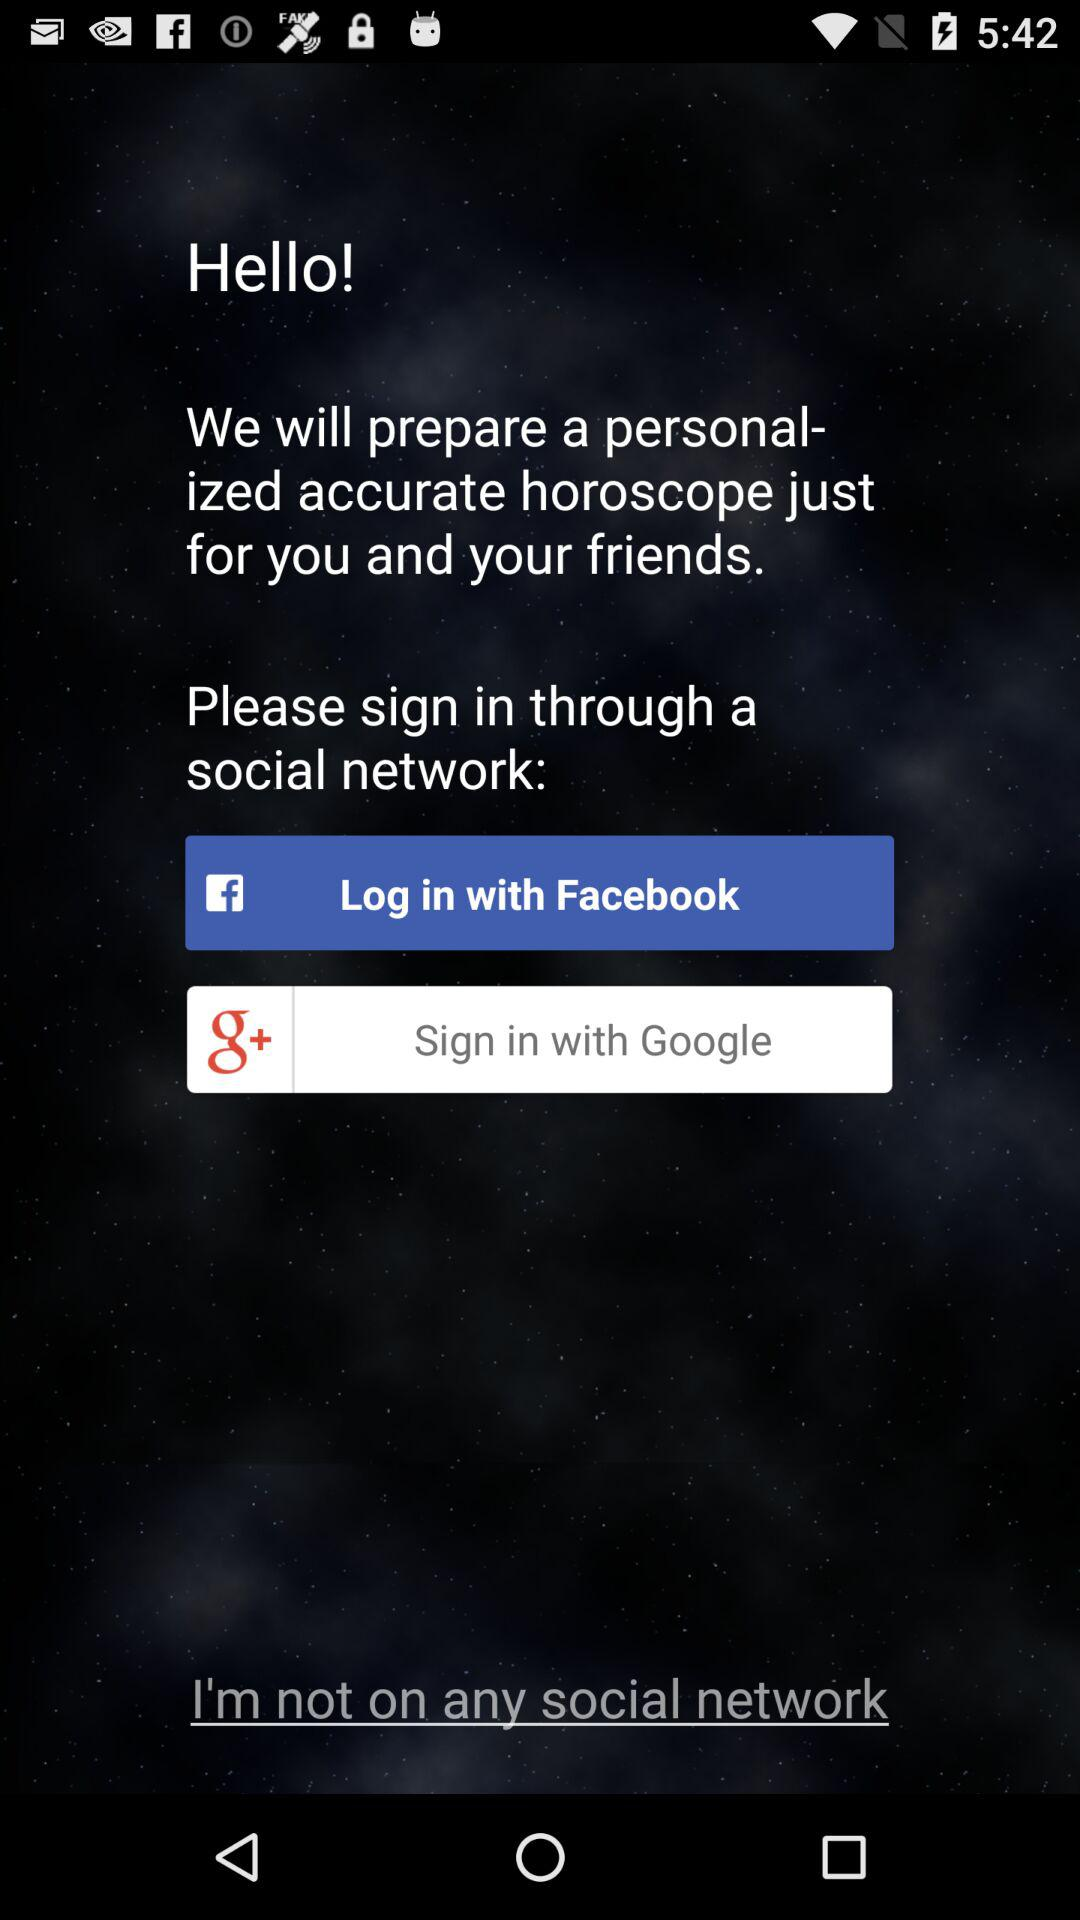How many social network sign in options are there?
Answer the question using a single word or phrase. 2 